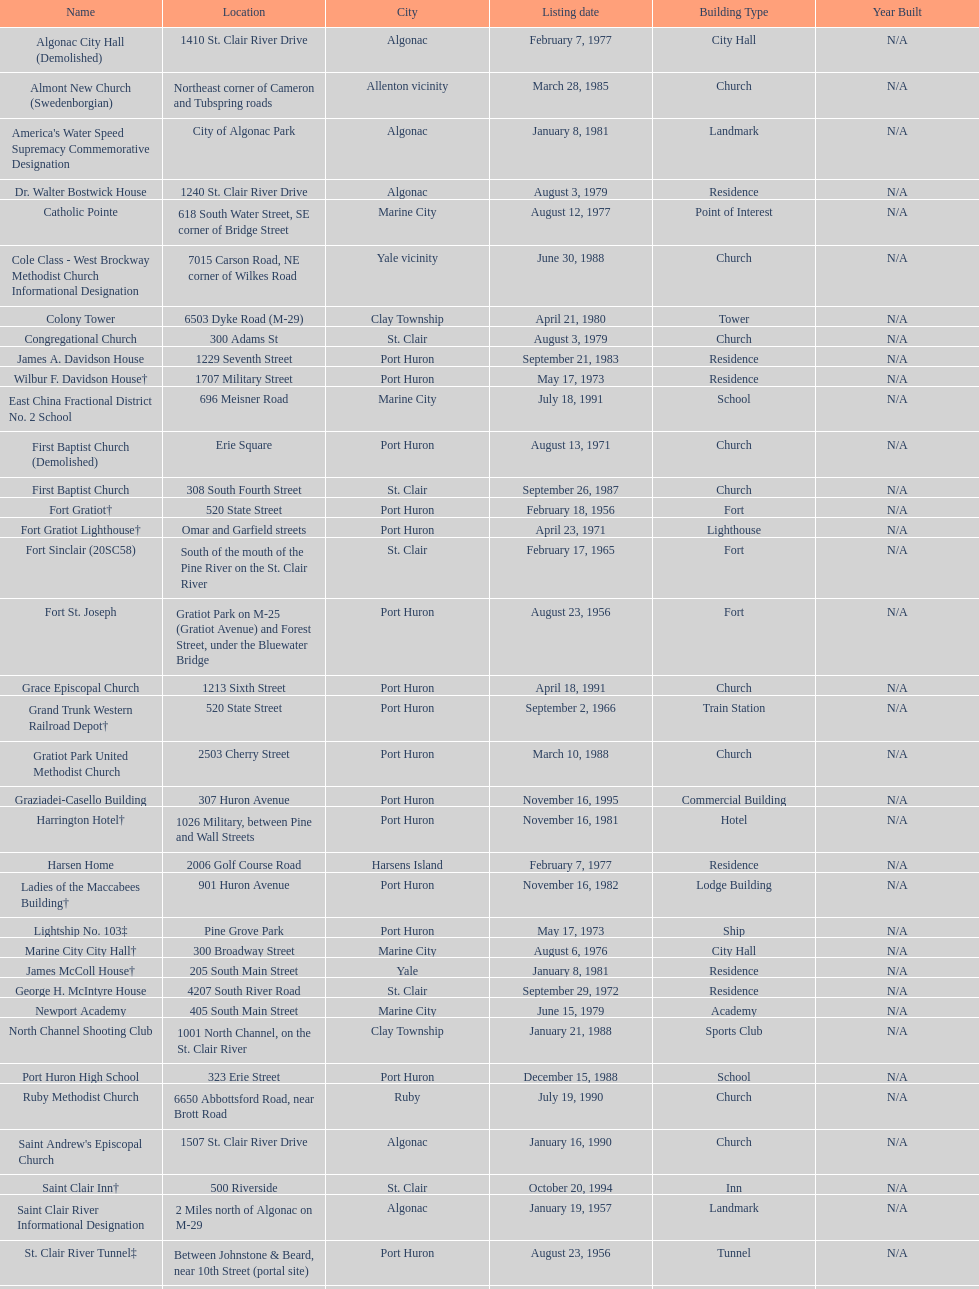Which city is home to the greatest number of historic sites, existing or demolished? Port Huron. 